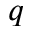<formula> <loc_0><loc_0><loc_500><loc_500>q</formula> 